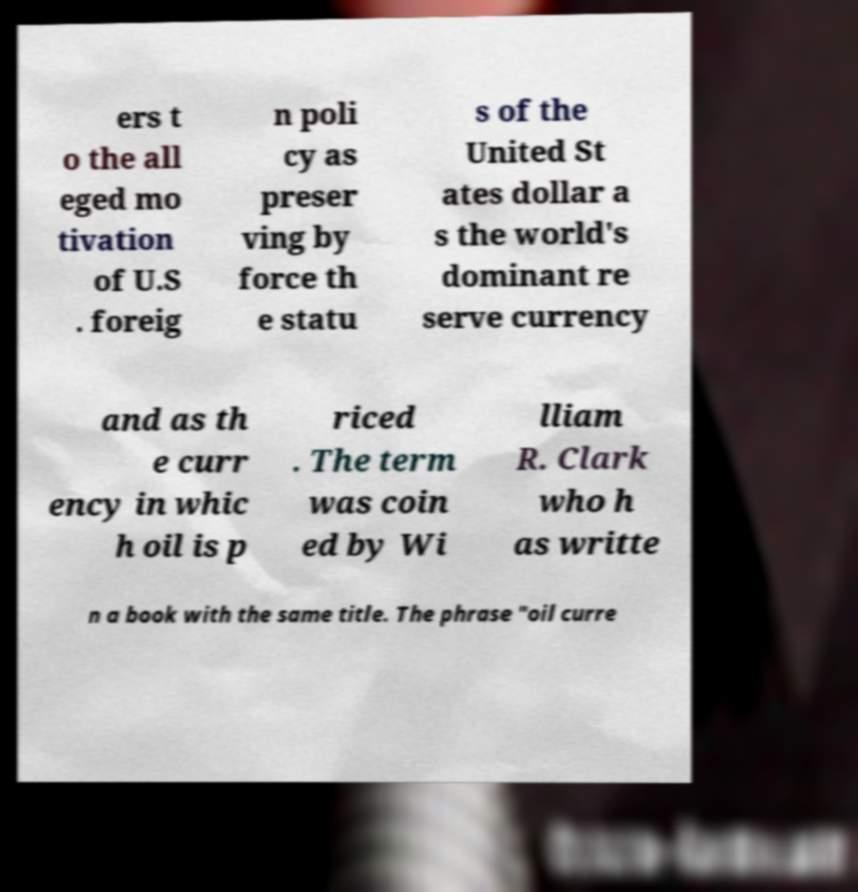For documentation purposes, I need the text within this image transcribed. Could you provide that? ers t o the all eged mo tivation of U.S . foreig n poli cy as preser ving by force th e statu s of the United St ates dollar a s the world's dominant re serve currency and as th e curr ency in whic h oil is p riced . The term was coin ed by Wi lliam R. Clark who h as writte n a book with the same title. The phrase "oil curre 